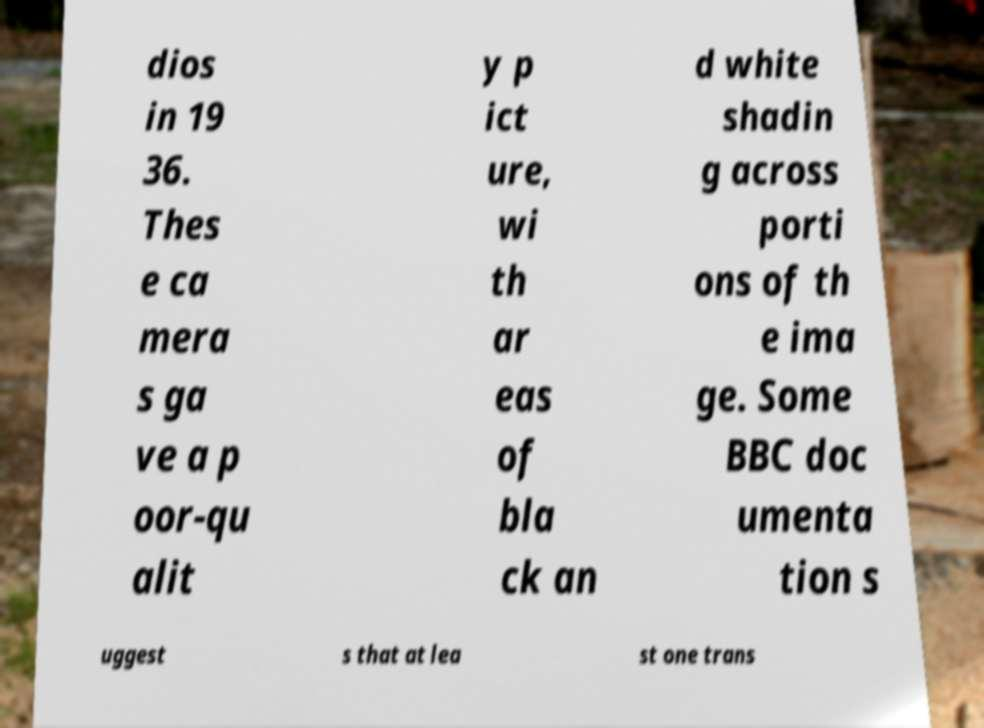Please read and relay the text visible in this image. What does it say? dios in 19 36. Thes e ca mera s ga ve a p oor-qu alit y p ict ure, wi th ar eas of bla ck an d white shadin g across porti ons of th e ima ge. Some BBC doc umenta tion s uggest s that at lea st one trans 